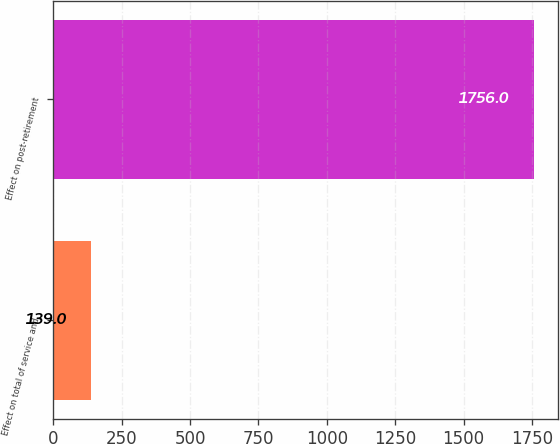Convert chart. <chart><loc_0><loc_0><loc_500><loc_500><bar_chart><fcel>Effect on total of service and<fcel>Effect on post-retirement<nl><fcel>139<fcel>1756<nl></chart> 